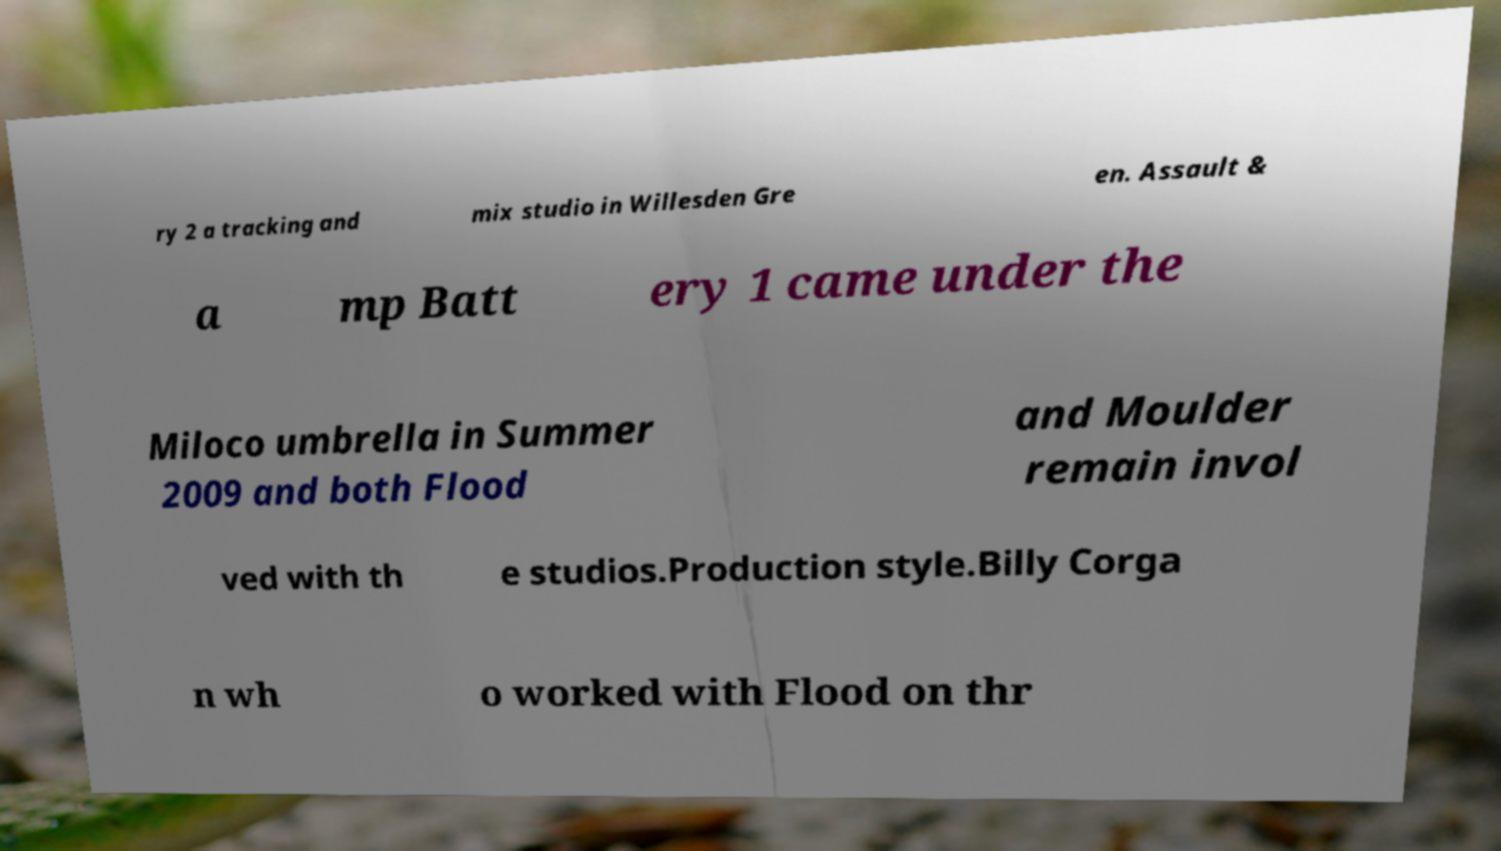Could you assist in decoding the text presented in this image and type it out clearly? ry 2 a tracking and mix studio in Willesden Gre en. Assault & a mp Batt ery 1 came under the Miloco umbrella in Summer 2009 and both Flood and Moulder remain invol ved with th e studios.Production style.Billy Corga n wh o worked with Flood on thr 